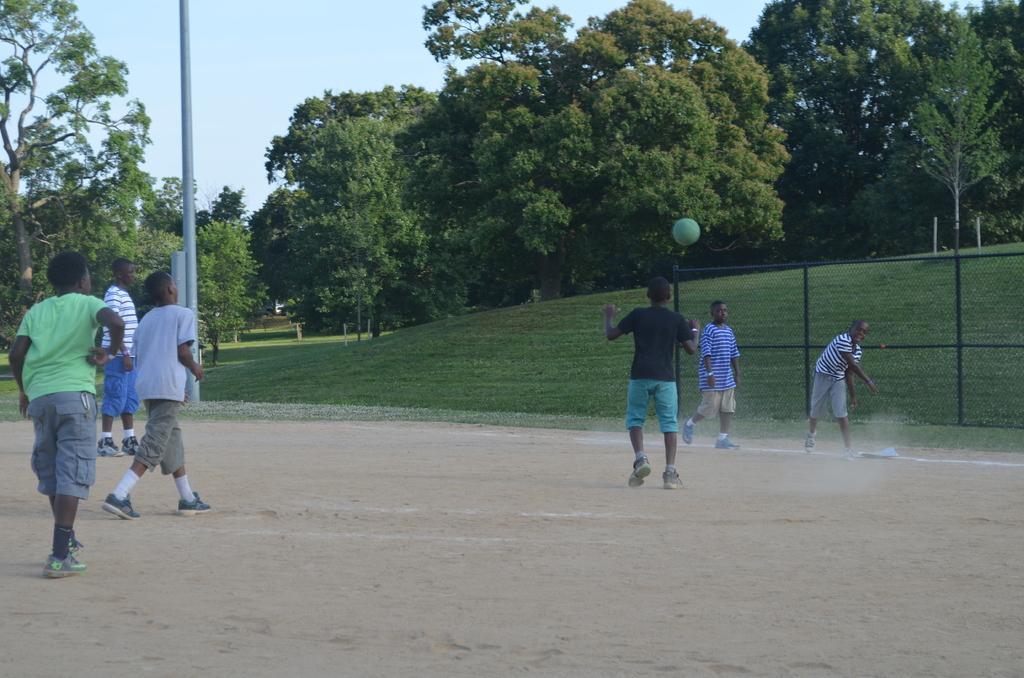Could you give a brief overview of what you see in this image? In the image there are few children playing on the ground and behind them there is a grass surface and trees. 